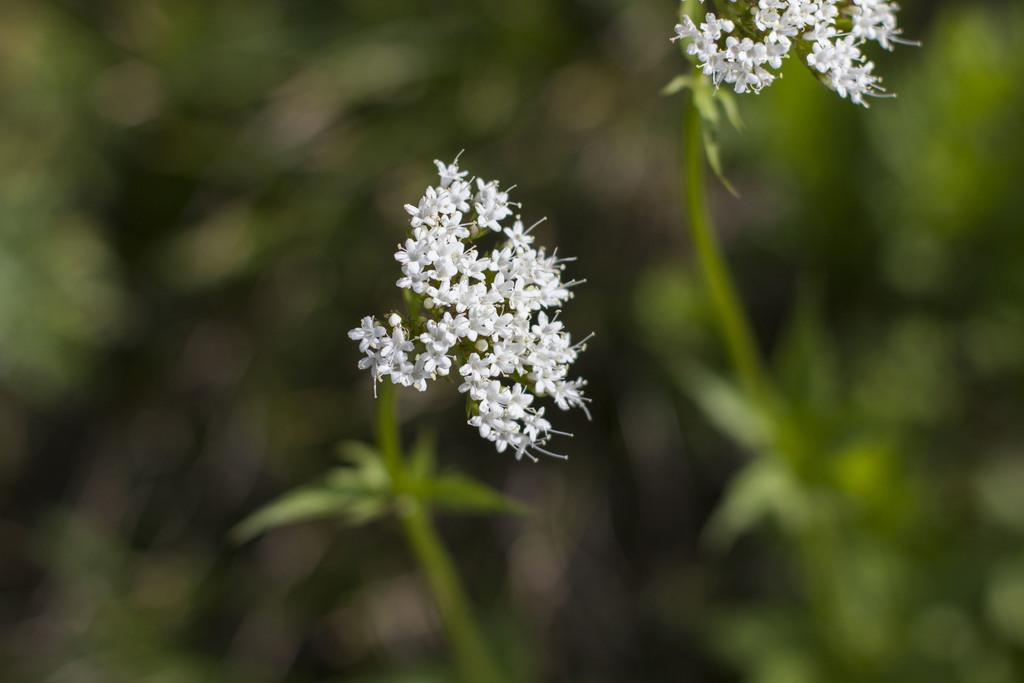What type of flowers are in the image? There are white color flowers in the image. Can you describe the background of the image? The background of the image is blurred. How does the border of the image display anger? The image does not display any border, nor does it depict any emotions such as anger. 